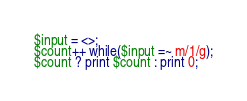<code> <loc_0><loc_0><loc_500><loc_500><_Perl_>$input = <>;
$count++ while($input =~ m/1/g);
$count ? print $count : print 0;</code> 